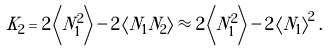Convert formula to latex. <formula><loc_0><loc_0><loc_500><loc_500>K _ { 2 } = 2 \left \langle N _ { 1 } ^ { 2 } \right \rangle - 2 \left \langle N _ { 1 } N _ { 2 } \right \rangle \approx 2 \left \langle N _ { 1 } ^ { 2 } \right \rangle - 2 \left \langle N _ { 1 } \right \rangle ^ { 2 } .</formula> 